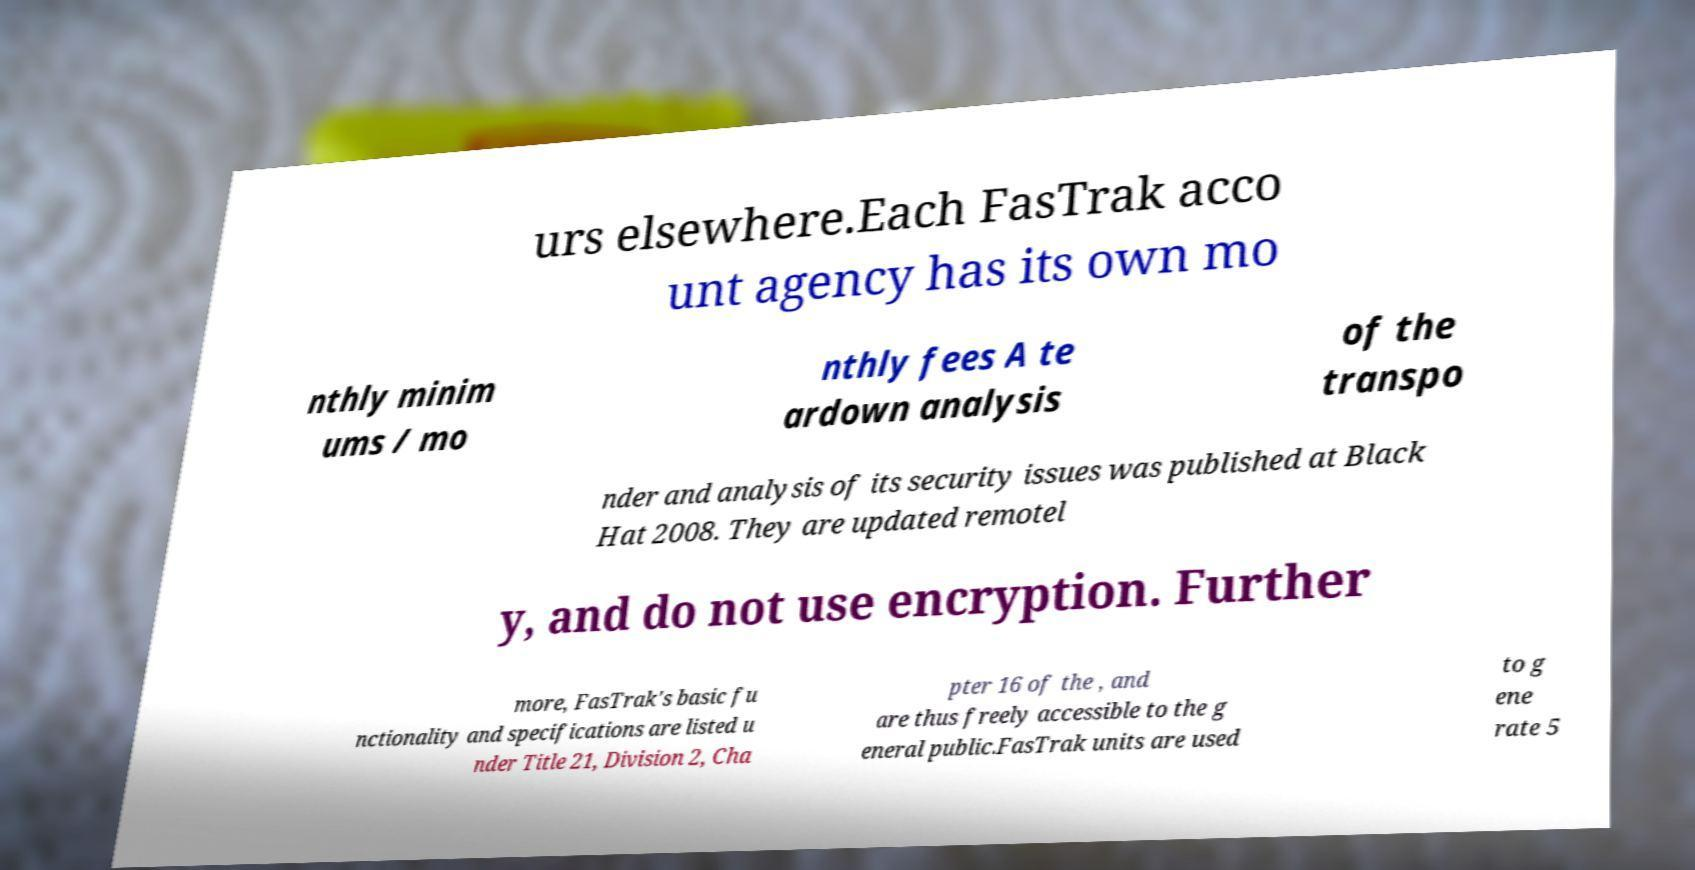There's text embedded in this image that I need extracted. Can you transcribe it verbatim? urs elsewhere.Each FasTrak acco unt agency has its own mo nthly minim ums / mo nthly fees A te ardown analysis of the transpo nder and analysis of its security issues was published at Black Hat 2008. They are updated remotel y, and do not use encryption. Further more, FasTrak's basic fu nctionality and specifications are listed u nder Title 21, Division 2, Cha pter 16 of the , and are thus freely accessible to the g eneral public.FasTrak units are used to g ene rate 5 